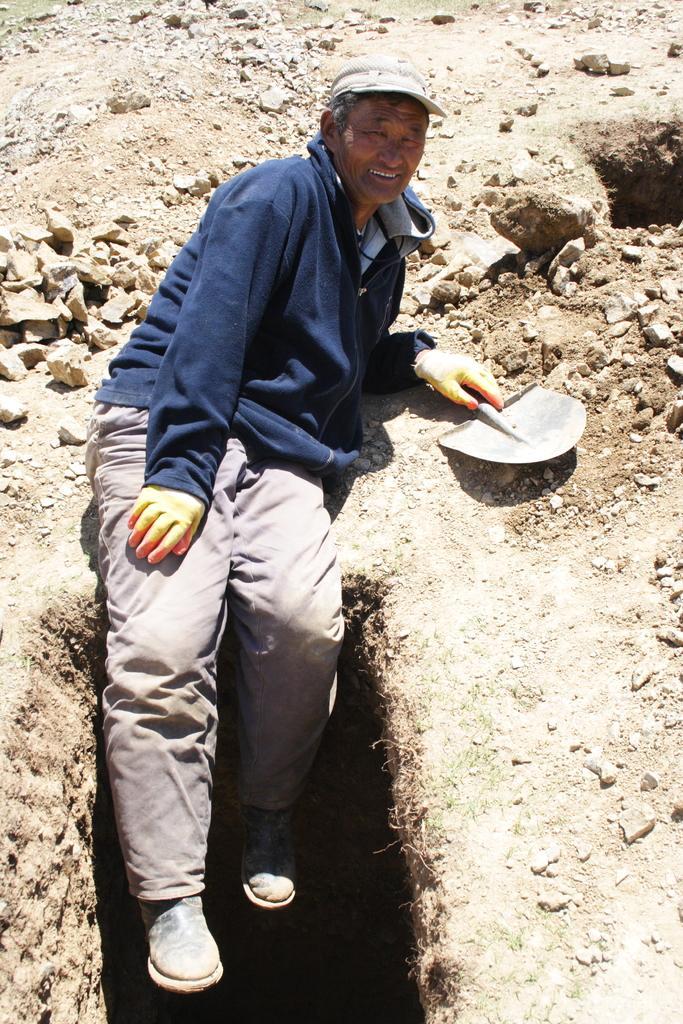Can you describe this image briefly? In the image we can see there is a man sitting on the ground and he holding shovel. He is wearing hand gloves and there are stones and mud on the ground. 